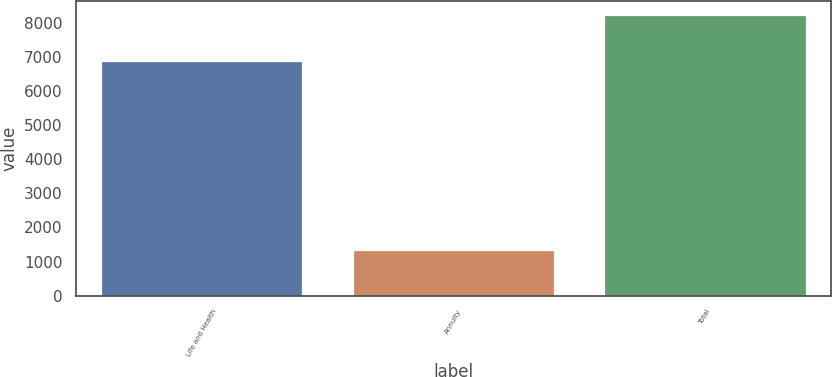<chart> <loc_0><loc_0><loc_500><loc_500><bar_chart><fcel>Life and Health<fcel>Annuity<fcel>Total<nl><fcel>6888.9<fcel>1338.8<fcel>8227.7<nl></chart> 